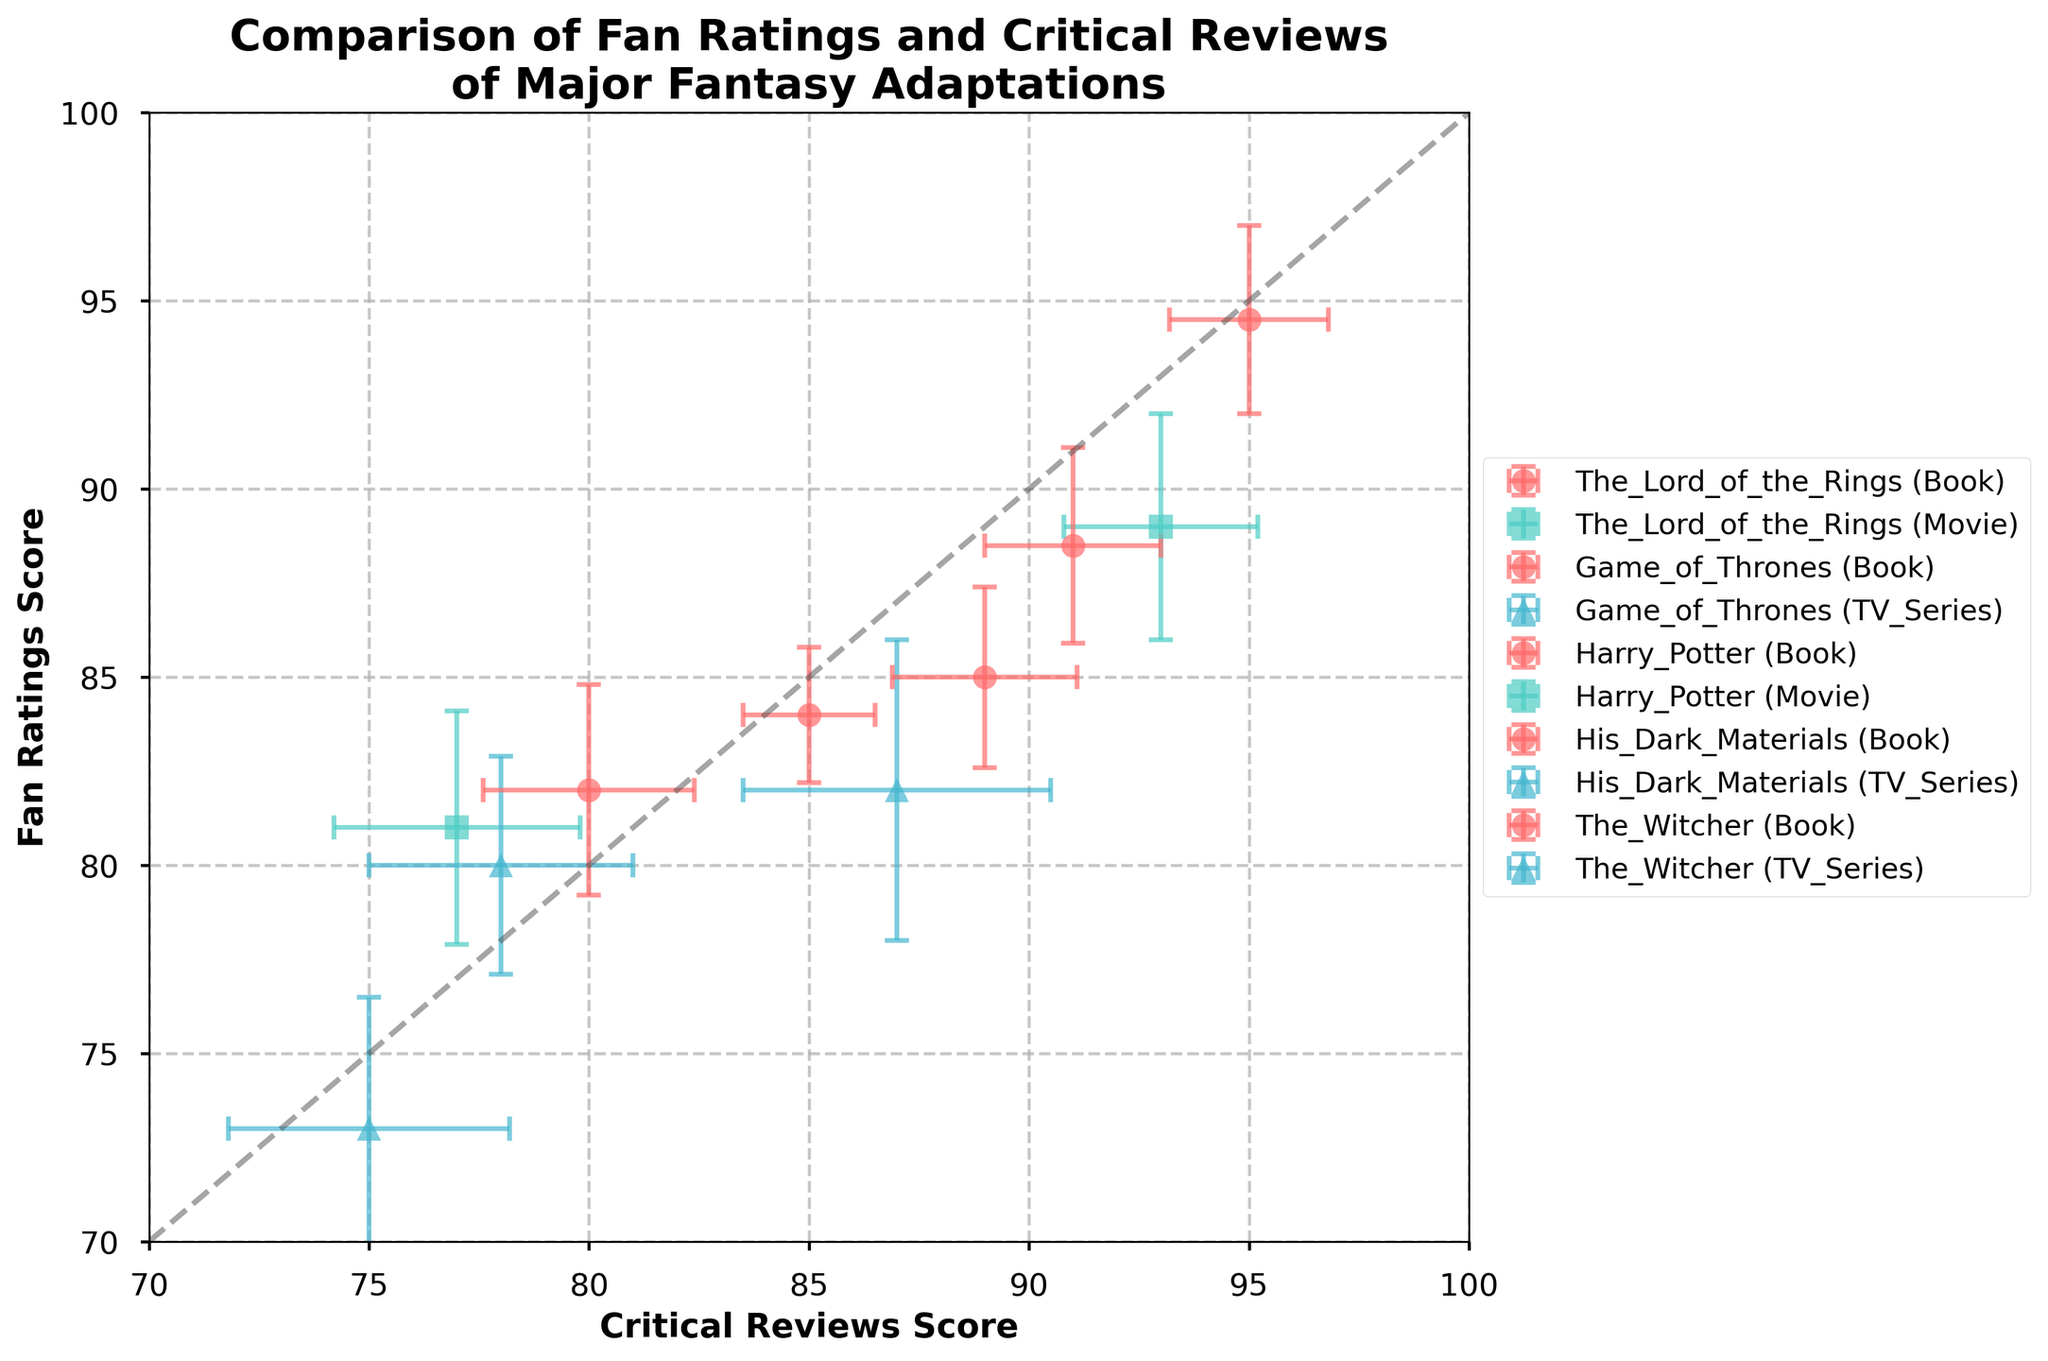What is the title of the figure? The title is located at the top of the figure and summarizes the main topic. It reads "Comparison of Fan Ratings and Critical Reviews of Major Fantasy Adaptations (Books vs. Movies/TV Series)"
Answer: Comparison of Fan Ratings and Critical Reviews of Major Fantasy Adaptations (Books vs. Movies/TV Series) What do the axes represent? The x-axis and y-axis labels explain what each axis represents. The x-axis represents "Critical Reviews Score," and the y-axis represents "Fan Ratings Score."
Answer: x-axis: Critical Reviews Score, y-axis: Fan Ratings Score Which adaptation has the highest fan rating for its TV series? The points representing TV series are marked with a triangle. Among the triangles, "Game_of_Thrones" has the highest fan rating score at 82.
Answer: Game of Thrones Among the books, which one received the lowest critical review score? Look at the circle markers representing books and compare their x-axis (Critical Reviews Score). "Harry_Potter" has the lowest score at 85.
Answer: Harry Potter Compare the fan ratings for The Lord of the Rings book and movie. Which one is higher? The fan ratings for the book and movie are represented by different markers on the y-axis. The book has a fan rating of 94.5, while the movie has 89. Hence, the book's rating is higher.
Answer: The Lord of the Rings book What is the difference in critical reviews score between "Game of Thrones" book and TV series? Find the x-coordinates of the points representing the book and TV series. The book has a score of 91, and the TV series has 87. The difference is 91 - 87 = 4.
Answer: 4 Which adaptation shows the largest error in fan ratings in its movie version? Examine the error bars in the y-axis for markers representing movies (square markers). "Harry_Potter" has the largest fan error at 3.1.
Answer: Harry Potter Is there any adaptation where both the book and its screen adaptation (movie/TV series) have more than 85 fan ratings? Check the fan ratings (y-axis) for both books and their screen adaptations. "The_Lord_of_the_Rings" book (94.5) and movie (89) both exceed 85 fan ratings.
Answer: The Lord of the Rings For which adaptation is the difference between critical reviews and fan ratings the most significant for its TV series? Calculate the absolute difference between critical reviews and fan ratings for each TV series, shown as triangles. "Game_of_Thrones" TV series has a 5-point difference (87 - 82).
Answer: Game of Thrones Which book adaptation is closest to the diagonal line indicating equal fan ratings and critical reviews? The diagonal line represents equal ratings on both axes. "Harry_Potter" book's point is closest to this line with almost matching critical review (85) and fan rating (84).
Answer: Harry Potter 